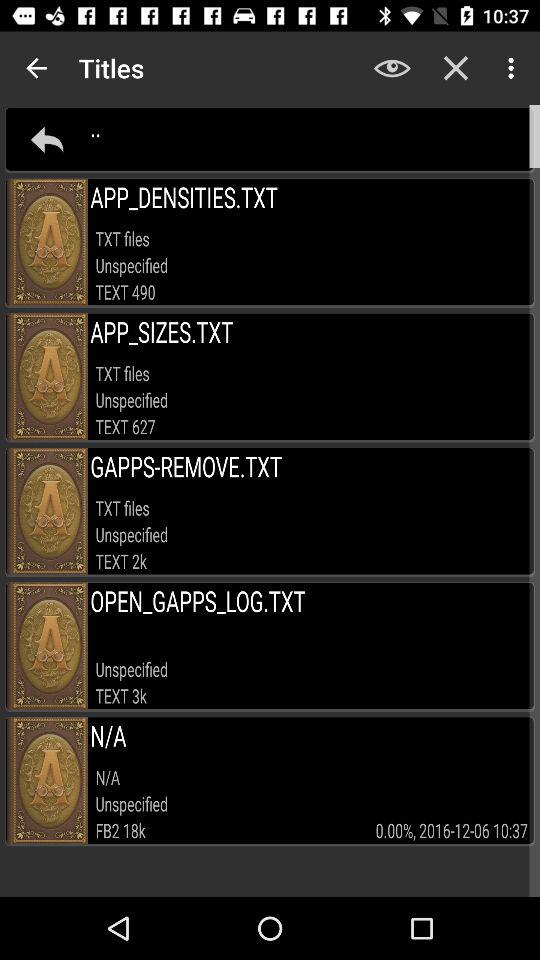What is the mentioned date? The mentioned date is December 6, 2016. 